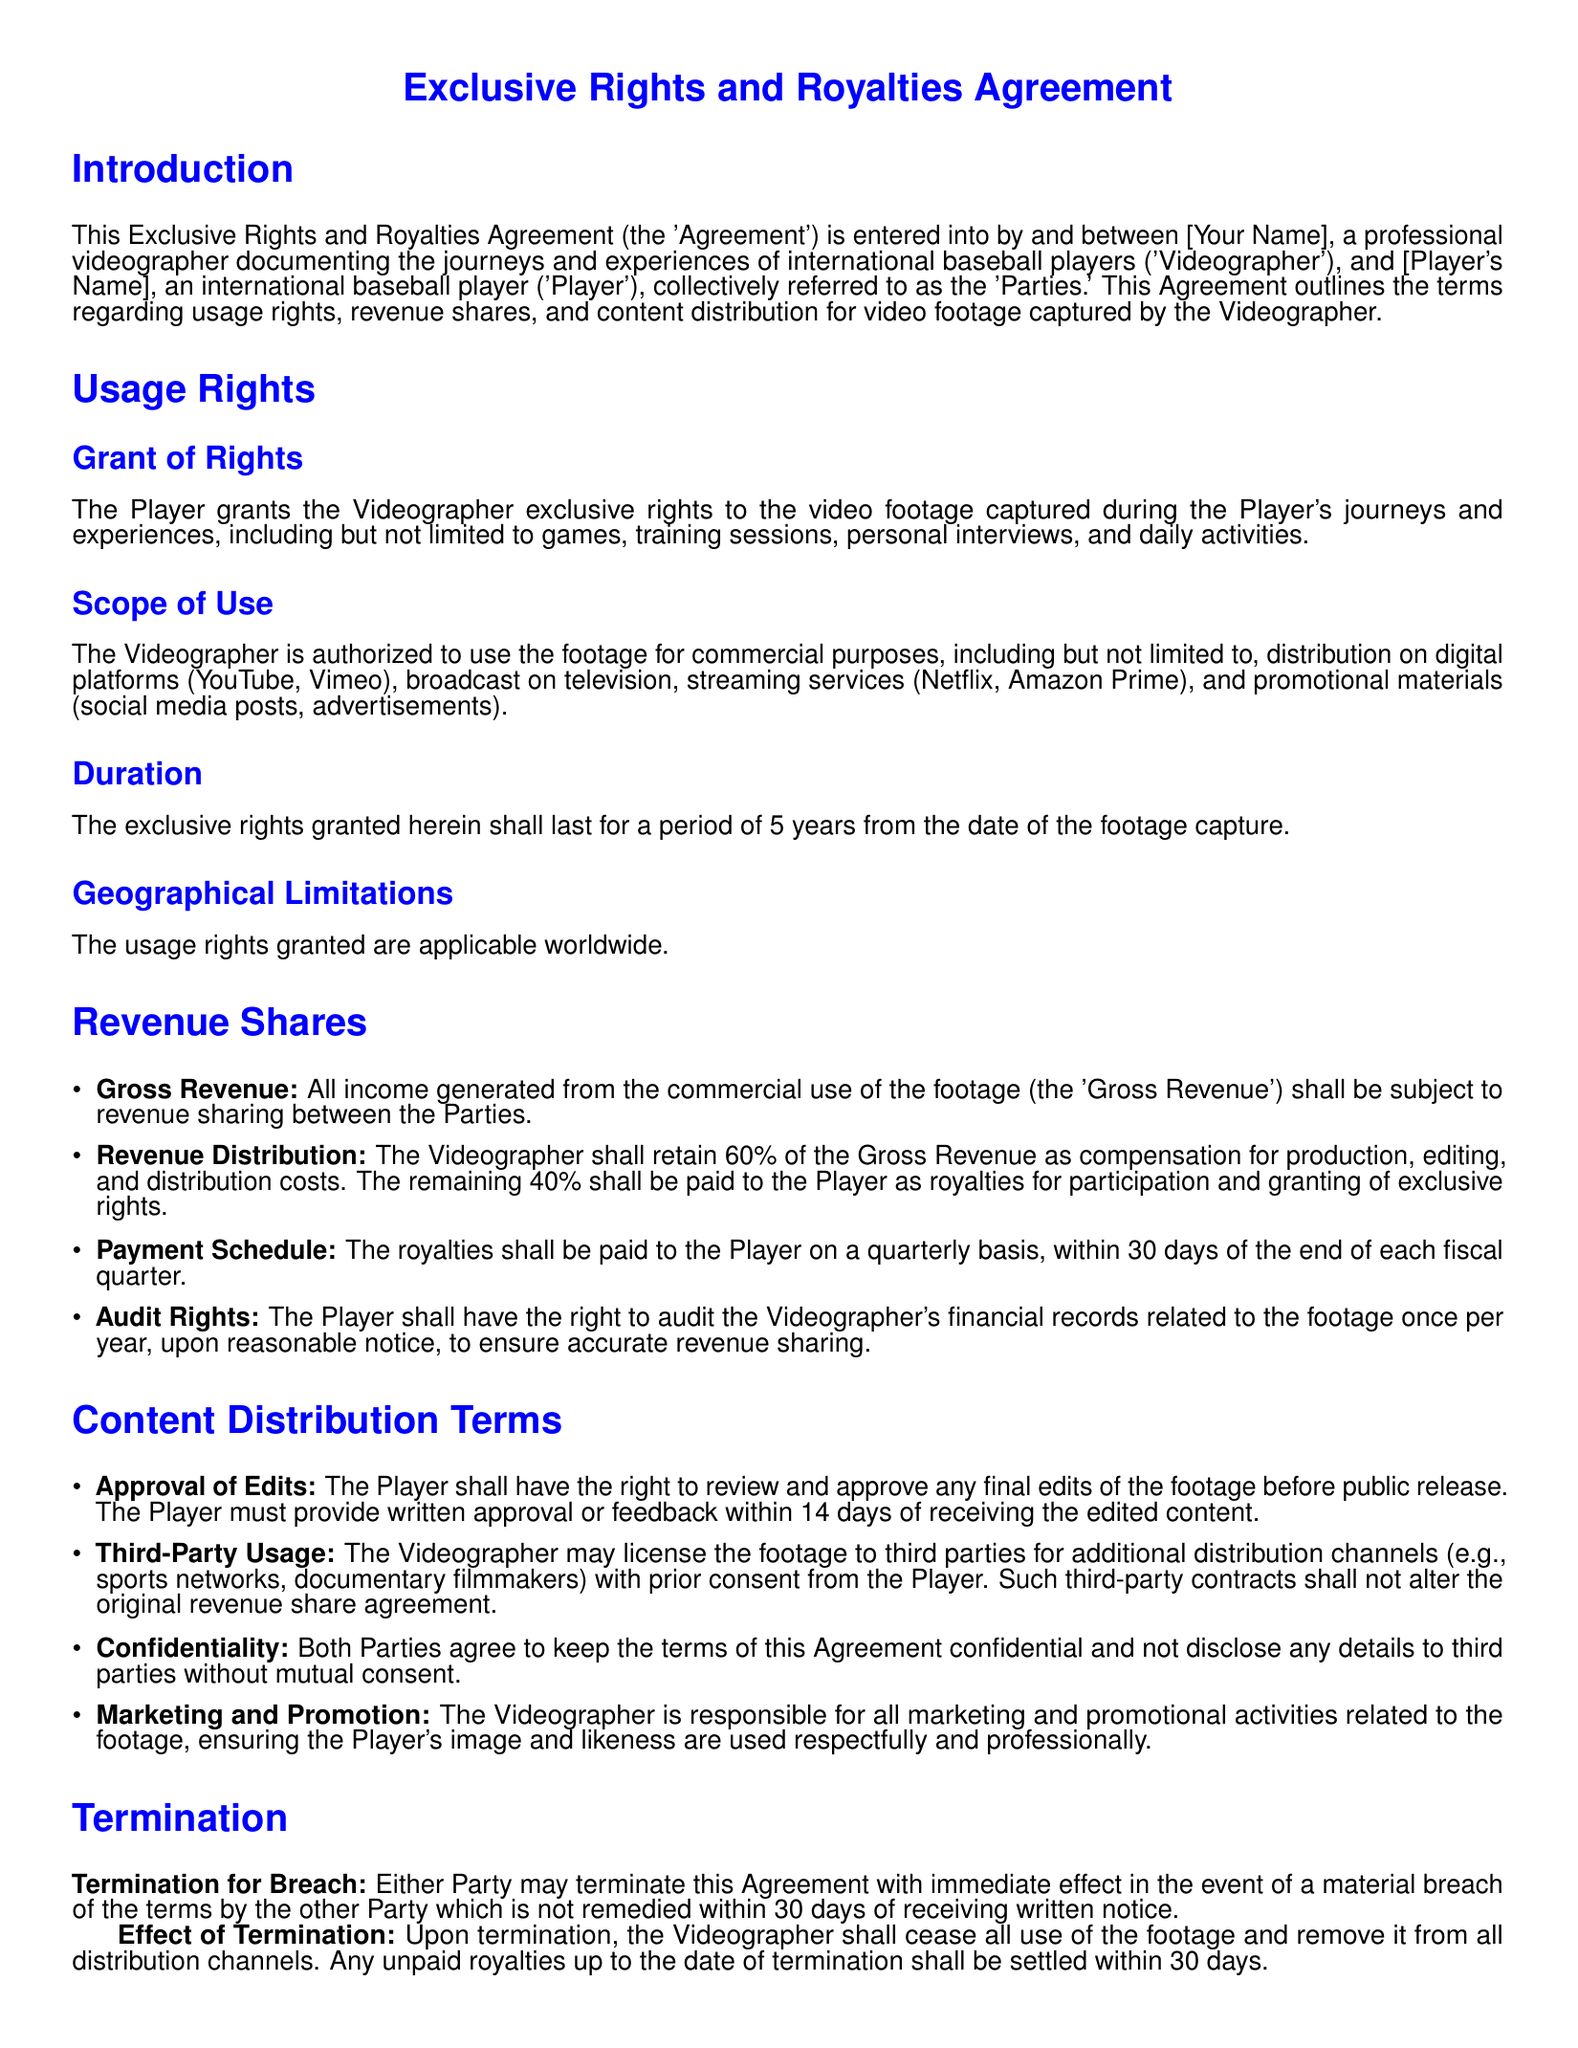What is the duration of the exclusive rights? The duration of the exclusive rights is specified to last for a period of 5 years from the date of the footage capture.
Answer: 5 years Who retains the majority of the Gross Revenue? The agreement states that the Videographer shall retain 60% of the Gross Revenue as compensation for various costs.
Answer: Videographer How often are royalties paid to the Player? The document mentions that royalties are to be paid to the Player on a quarterly basis.
Answer: Quarterly What percentage of the Gross Revenue does the Player receive? The document states that the Player receives 40% of the Gross Revenue as royalties.
Answer: 40% What is required of the Player before the public release of footage? The Player must review and approve the final edits of the footage before public release.
Answer: Review and approval How long does the Player have to provide feedback on edited content? The agreement specifies that the Player must provide written approval or feedback within 14 days of receiving the edited content.
Answer: 14 days What action can either Party take for a material breach? The document allows either Party to terminate the Agreement with immediate effect in the event of a material breach.
Answer: Terminate Which Party is responsible for marketing and promotion? The document states that the Videographer is responsible for all marketing and promotional activities related to the footage.
Answer: Videographer 